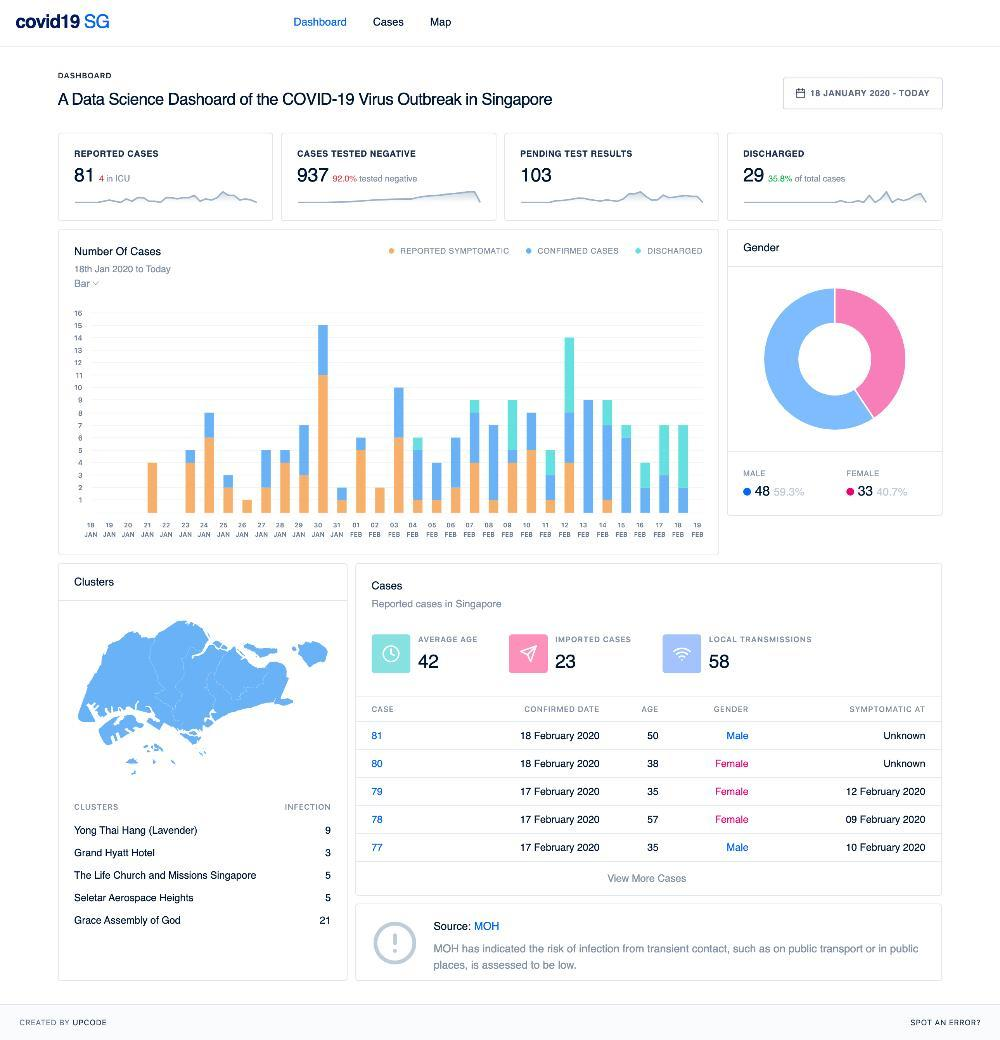How many imported cases?
Answer the question with a short phrase. 23 How many pending test results? 103 What is the percentage of tested negative cases? 92.0% What is the average age? 42 How many persons are in ICU? 4 